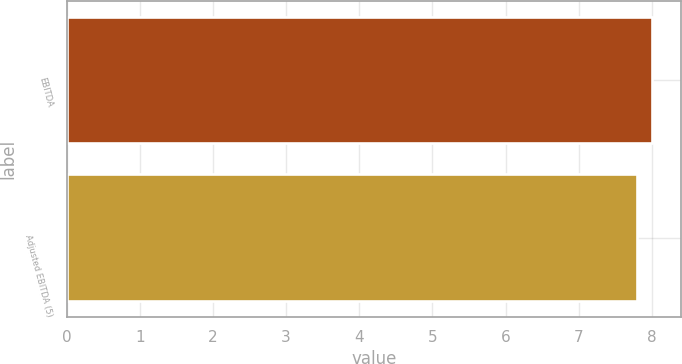<chart> <loc_0><loc_0><loc_500><loc_500><bar_chart><fcel>EBITDA<fcel>Adjusted EBITDA (5)<nl><fcel>8<fcel>7.8<nl></chart> 